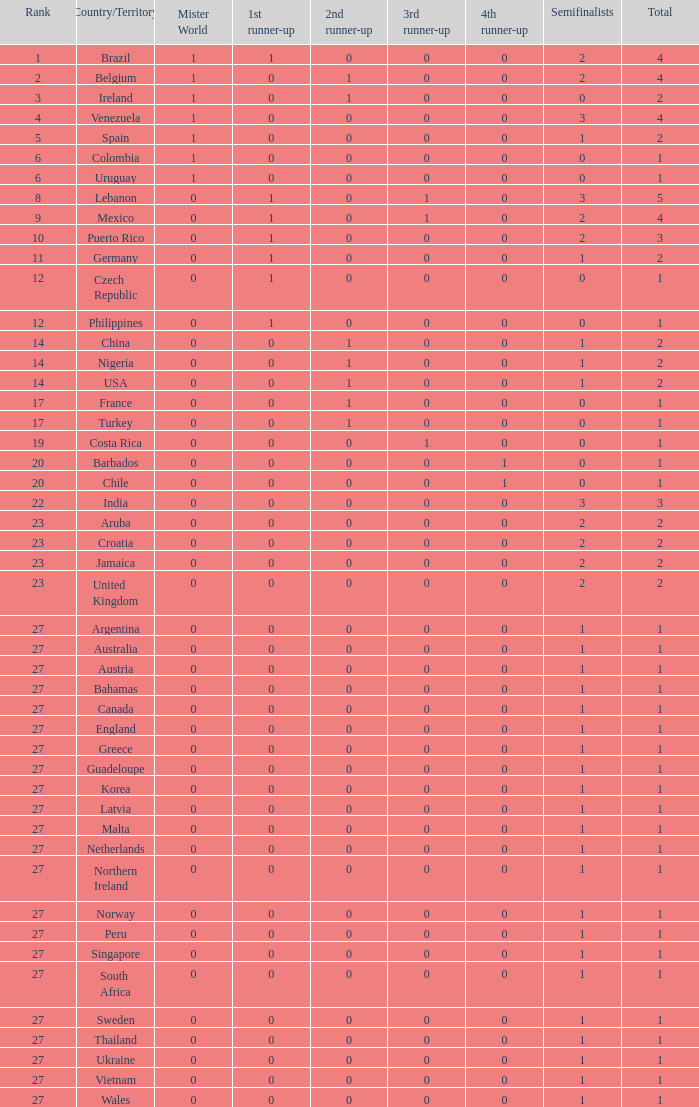How many 3rd runner up values does Turkey have? 1.0. 